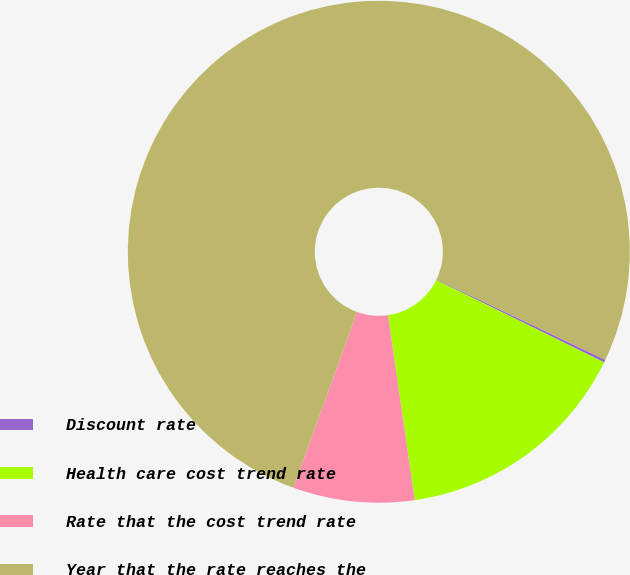Convert chart to OTSL. <chart><loc_0><loc_0><loc_500><loc_500><pie_chart><fcel>Discount rate<fcel>Health care cost trend rate<fcel>Rate that the cost trend rate<fcel>Year that the rate reaches the<nl><fcel>0.18%<fcel>15.45%<fcel>7.82%<fcel>76.54%<nl></chart> 